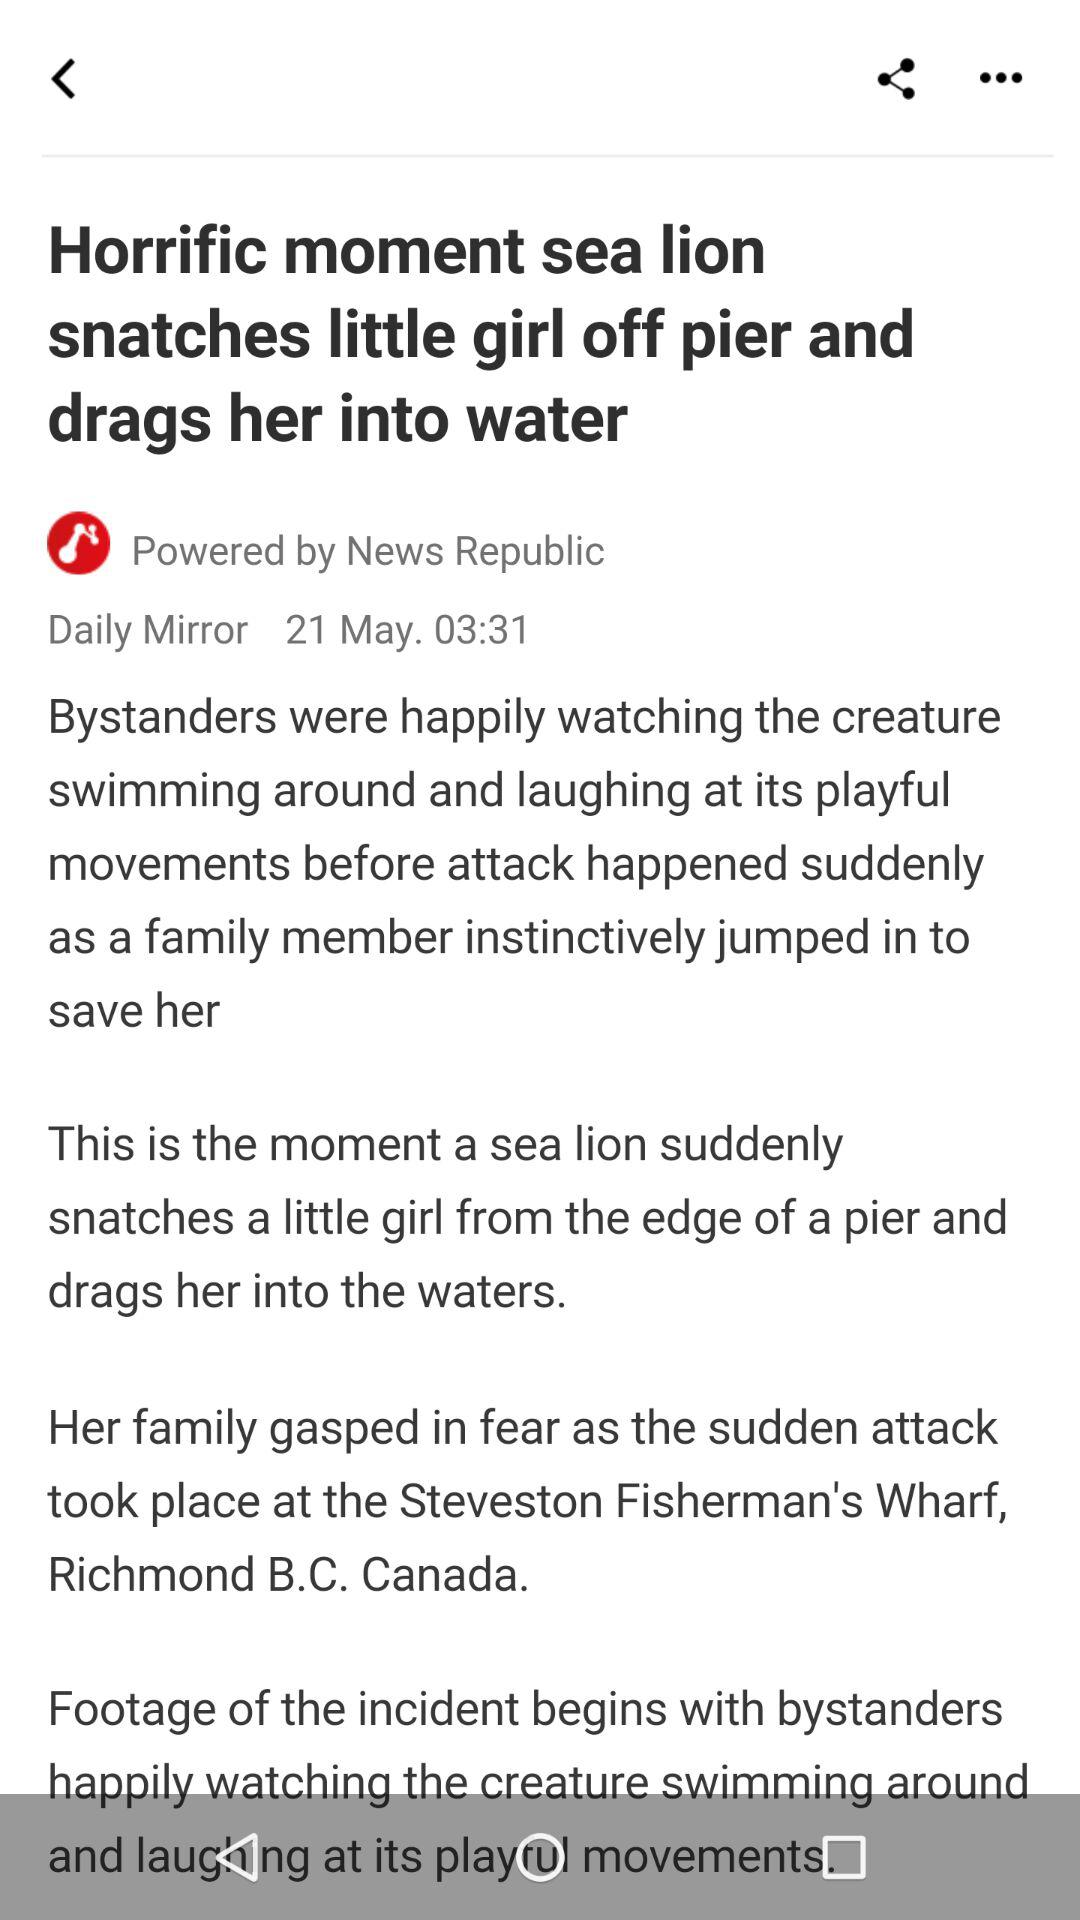When was the news uploaded? The news was uploaded on May 21 at 03:31. 